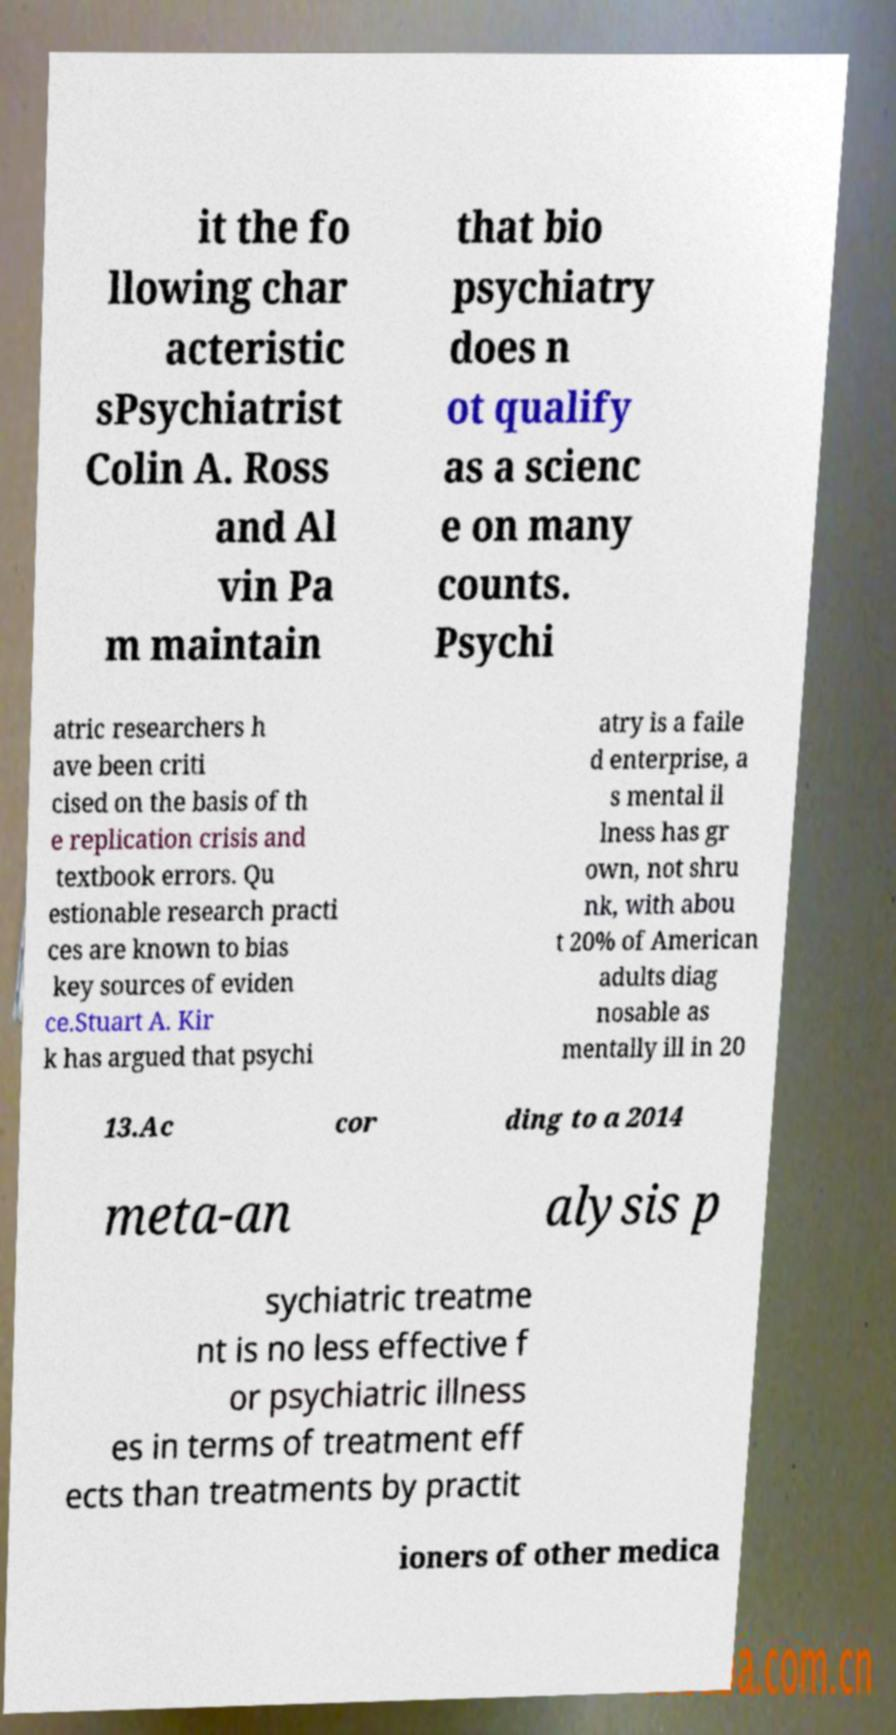Can you read and provide the text displayed in the image?This photo seems to have some interesting text. Can you extract and type it out for me? it the fo llowing char acteristic sPsychiatrist Colin A. Ross and Al vin Pa m maintain that bio psychiatry does n ot qualify as a scienc e on many counts. Psychi atric researchers h ave been criti cised on the basis of th e replication crisis and textbook errors. Qu estionable research practi ces are known to bias key sources of eviden ce.Stuart A. Kir k has argued that psychi atry is a faile d enterprise, a s mental il lness has gr own, not shru nk, with abou t 20% of American adults diag nosable as mentally ill in 20 13.Ac cor ding to a 2014 meta-an alysis p sychiatric treatme nt is no less effective f or psychiatric illness es in terms of treatment eff ects than treatments by practit ioners of other medica 